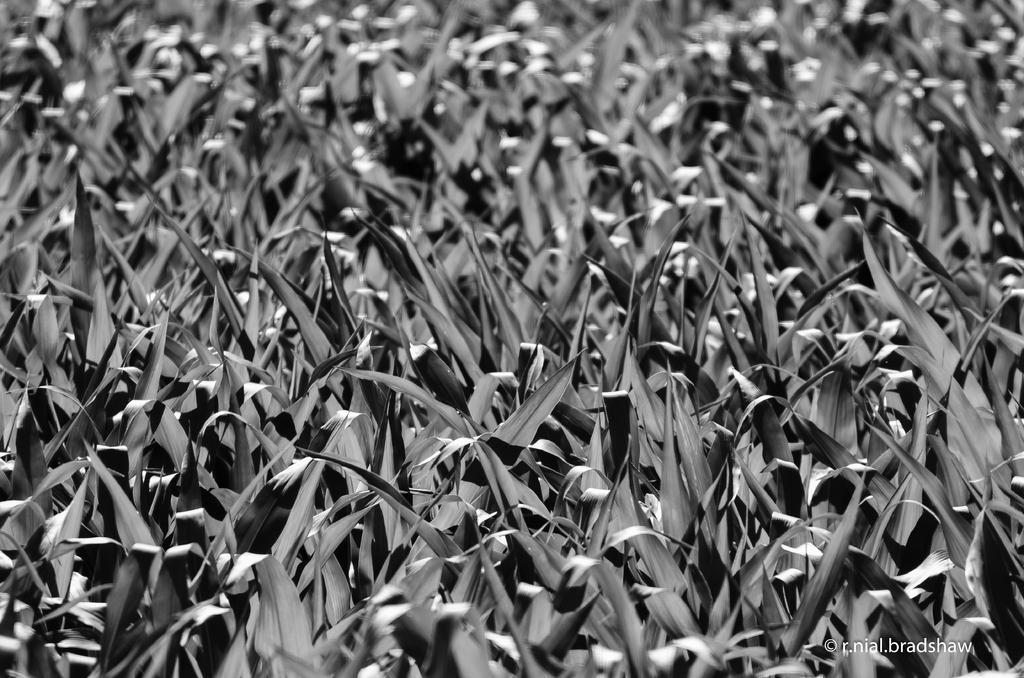Describe this image in one or two sentences. This is a black and white and white in color. In the image we can see leaves and a watermark. 